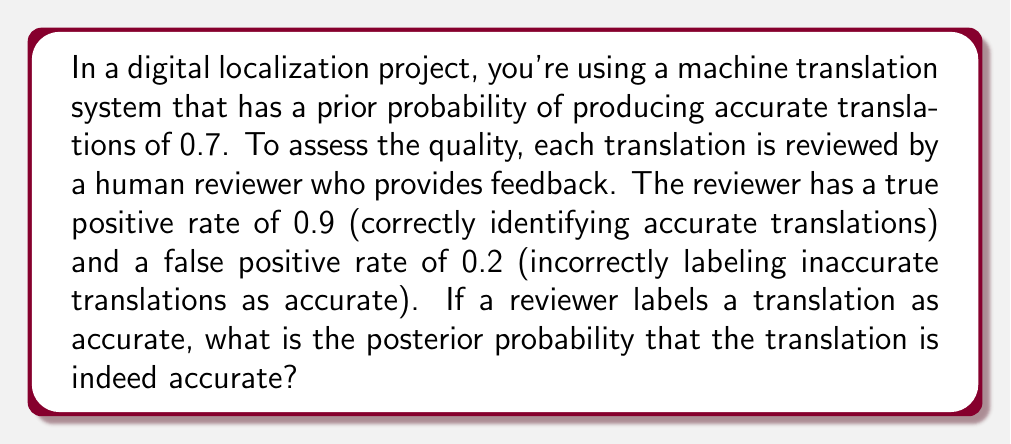Give your solution to this math problem. To solve this problem, we'll use Bayes' theorem. Let's define our events:

A: The translation is accurate
B: The reviewer labels the translation as accurate

We're given:
$P(A) = 0.7$ (prior probability)
$P(B|A) = 0.9$ (true positive rate)
$P(B|\neg A) = 0.2$ (false positive rate)

We want to find $P(A|B)$. Bayes' theorem states:

$$P(A|B) = \frac{P(B|A) \cdot P(A)}{P(B)}$$

To calculate $P(B)$, we use the law of total probability:

$$P(B) = P(B|A) \cdot P(A) + P(B|\neg A) \cdot P(\neg A)$$

Step 1: Calculate $P(\neg A)$
$P(\neg A) = 1 - P(A) = 1 - 0.7 = 0.3$

Step 2: Calculate $P(B)$
$P(B) = 0.9 \cdot 0.7 + 0.2 \cdot 0.3 = 0.63 + 0.06 = 0.69$

Step 3: Apply Bayes' theorem
$$P(A|B) = \frac{0.9 \cdot 0.7}{0.69} = \frac{0.63}{0.69} \approx 0.9130$$

Therefore, the posterior probability that the translation is accurate, given that the reviewer labeled it as accurate, is approximately 0.9130 or 91.30%.
Answer: $P(A|B) \approx 0.9130$ or 91.30% 